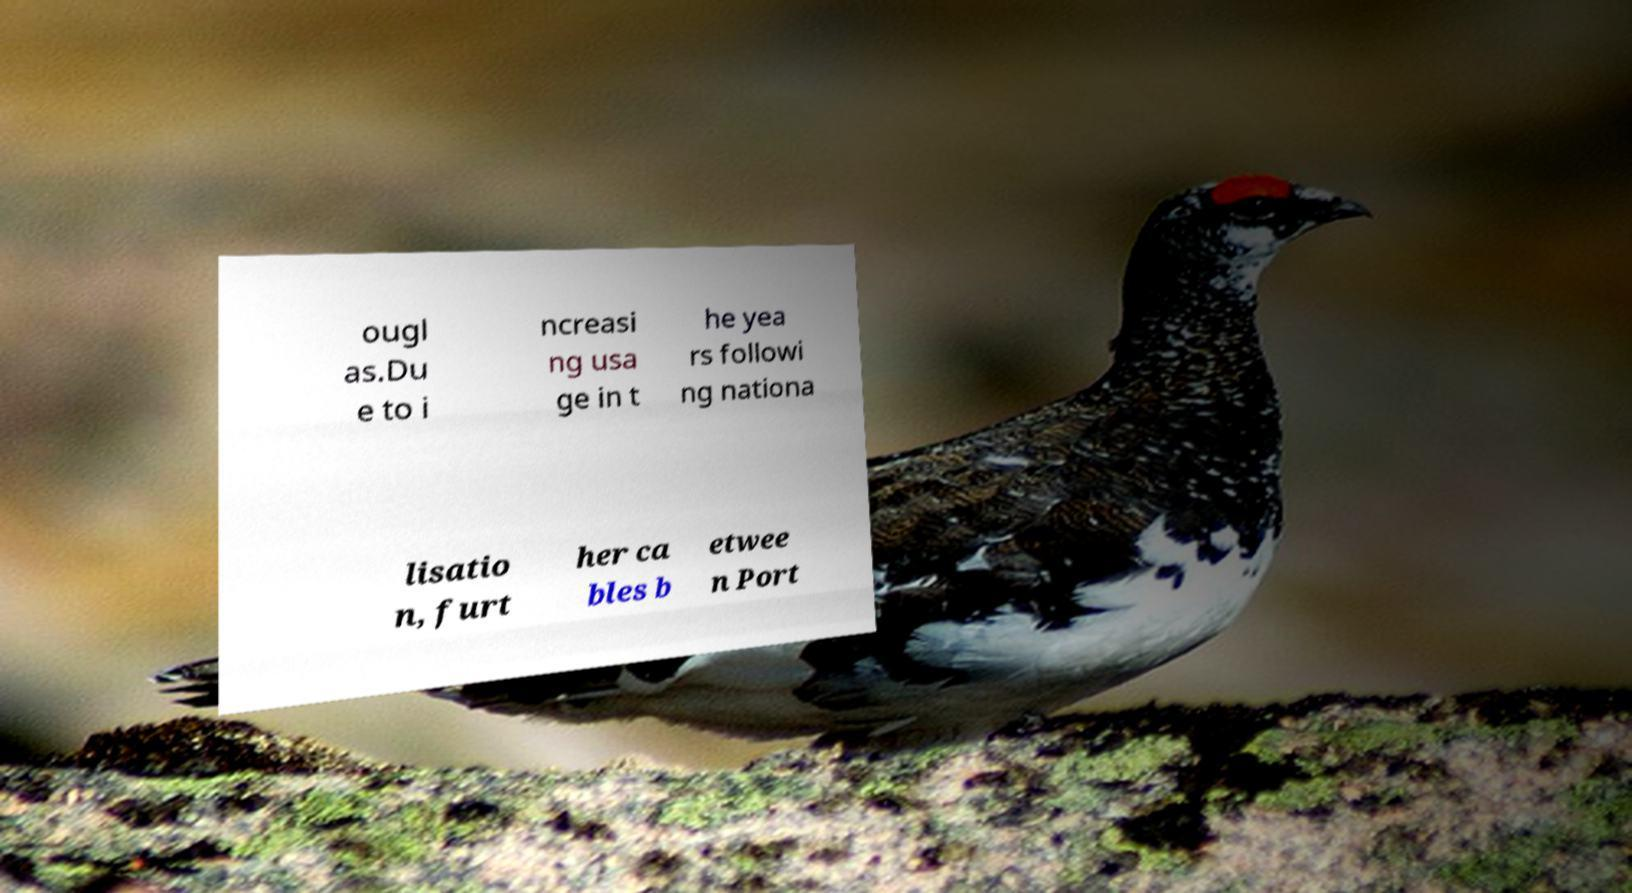Can you accurately transcribe the text from the provided image for me? ougl as.Du e to i ncreasi ng usa ge in t he yea rs followi ng nationa lisatio n, furt her ca bles b etwee n Port 